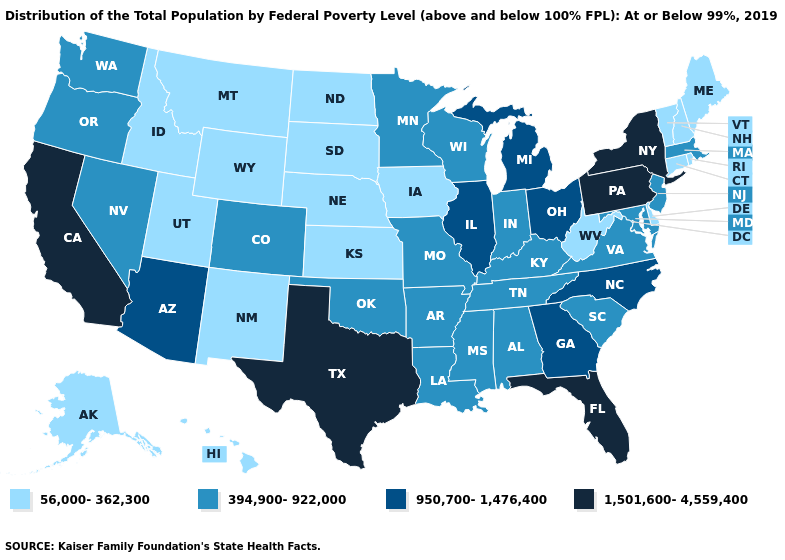Name the states that have a value in the range 950,700-1,476,400?
Give a very brief answer. Arizona, Georgia, Illinois, Michigan, North Carolina, Ohio. What is the value of Maine?
Short answer required. 56,000-362,300. Name the states that have a value in the range 1,501,600-4,559,400?
Keep it brief. California, Florida, New York, Pennsylvania, Texas. Among the states that border North Dakota , which have the highest value?
Answer briefly. Minnesota. Does Alabama have the lowest value in the USA?
Short answer required. No. How many symbols are there in the legend?
Quick response, please. 4. Among the states that border Connecticut , does New York have the highest value?
Concise answer only. Yes. What is the lowest value in states that border Maryland?
Keep it brief. 56,000-362,300. Name the states that have a value in the range 394,900-922,000?
Be succinct. Alabama, Arkansas, Colorado, Indiana, Kentucky, Louisiana, Maryland, Massachusetts, Minnesota, Mississippi, Missouri, Nevada, New Jersey, Oklahoma, Oregon, South Carolina, Tennessee, Virginia, Washington, Wisconsin. Among the states that border Oklahoma , does New Mexico have the lowest value?
Concise answer only. Yes. What is the value of Mississippi?
Concise answer only. 394,900-922,000. Does the first symbol in the legend represent the smallest category?
Quick response, please. Yes. How many symbols are there in the legend?
Concise answer only. 4. Among the states that border Tennessee , does Arkansas have the highest value?
Be succinct. No. Does Illinois have a higher value than Alabama?
Be succinct. Yes. 